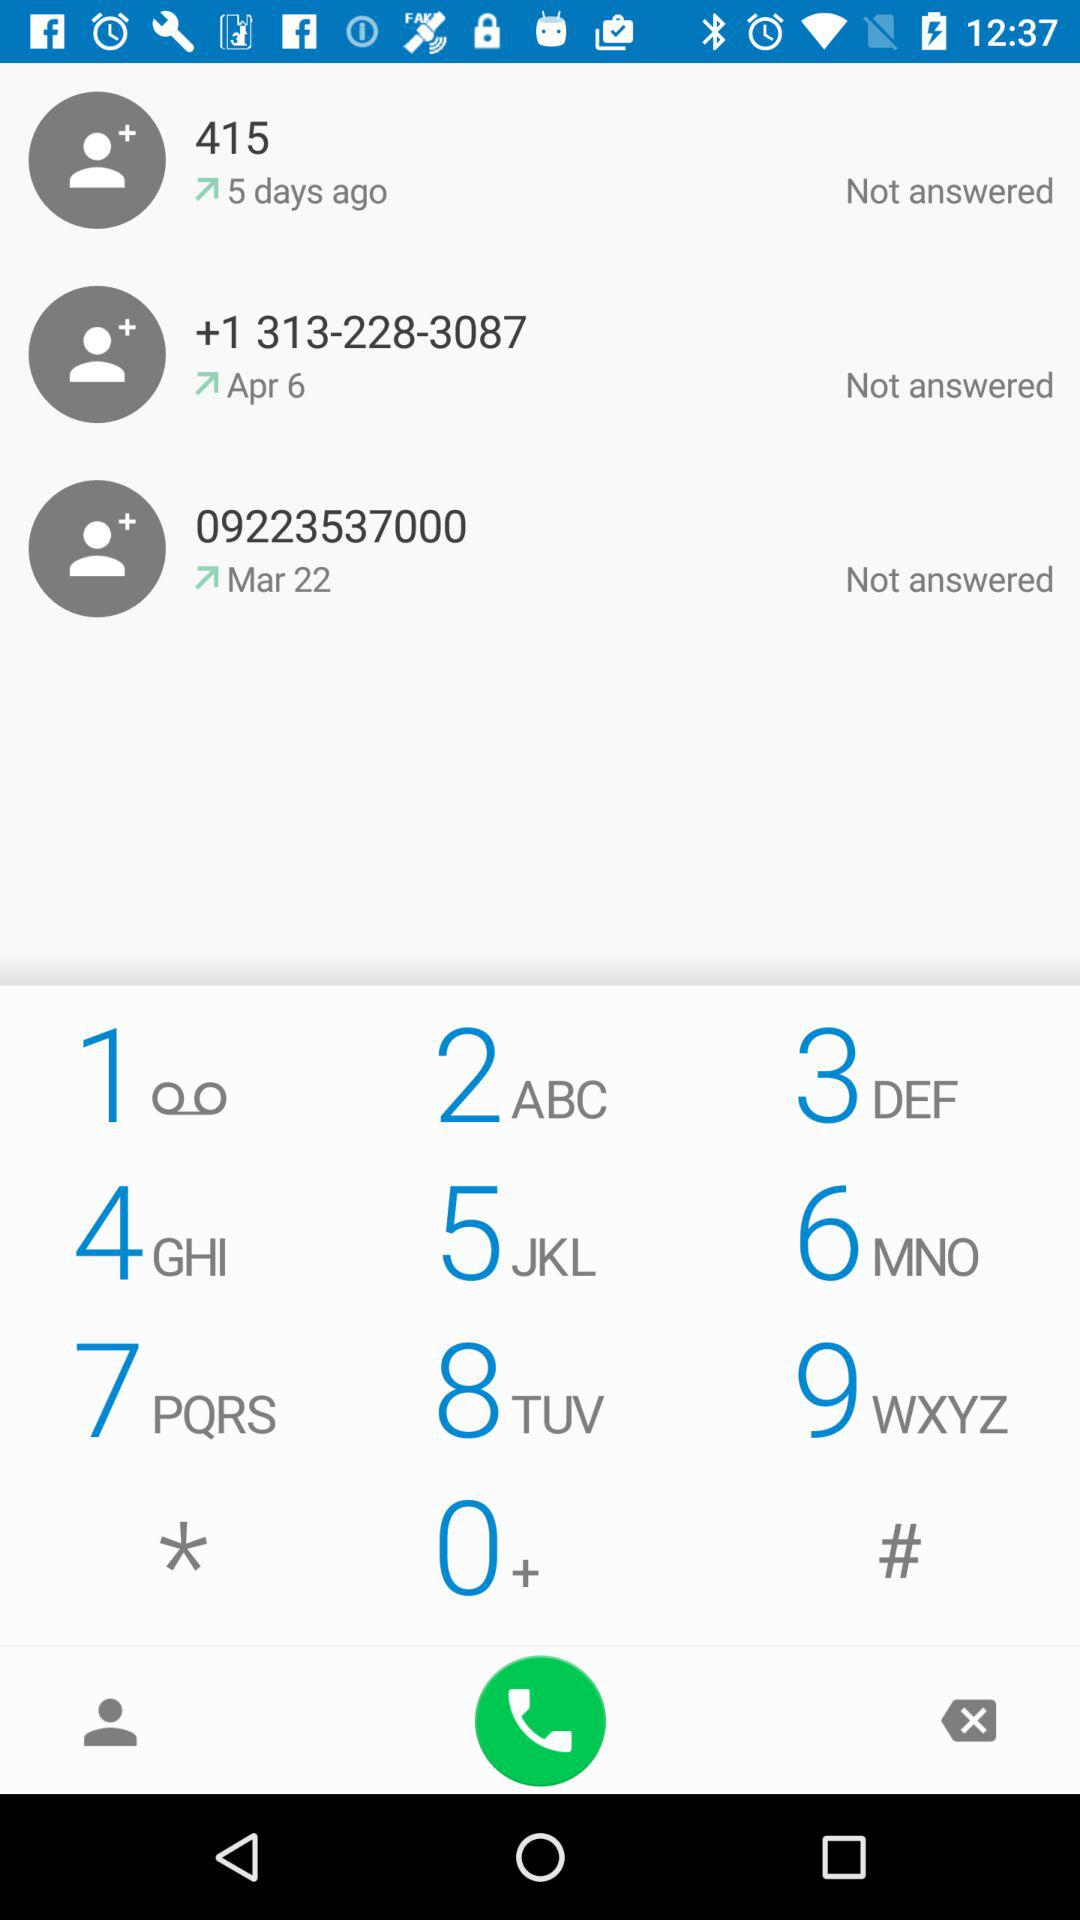From what number did I get the call on the 22nd of March? The number was 09223537000. 